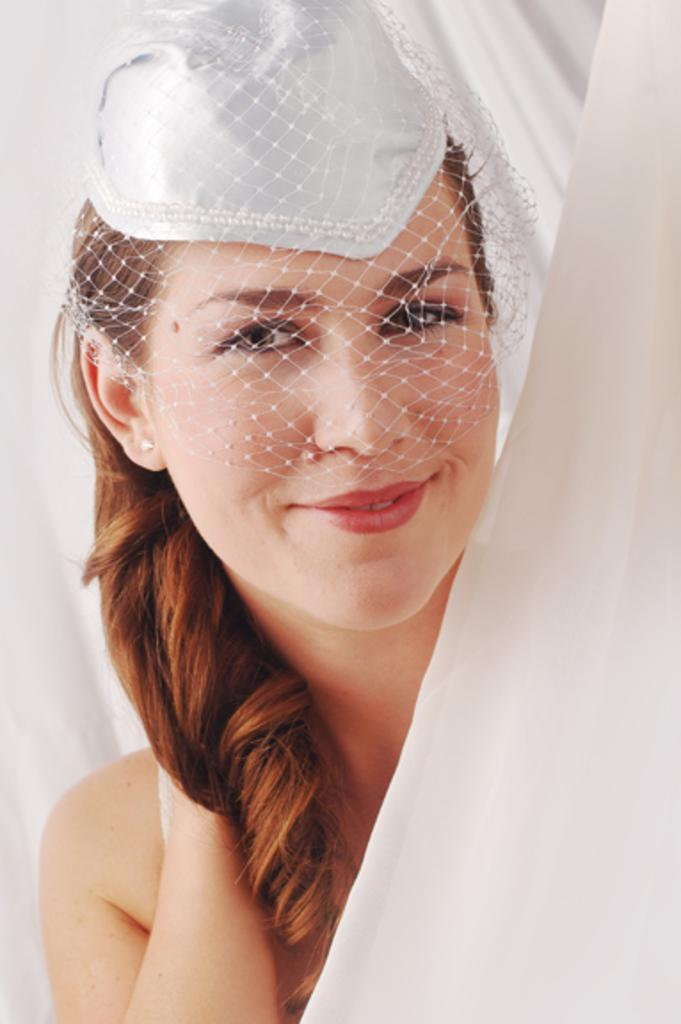Who is the main subject in the image? There is a woman in the image. What is covering the woman's face? The woman's face is covered with a net. What color is the background of the image? The background of the image is white. What song is the woman singing in the image? There is no indication in the image that the woman is singing, and no song can be heard or seen. 